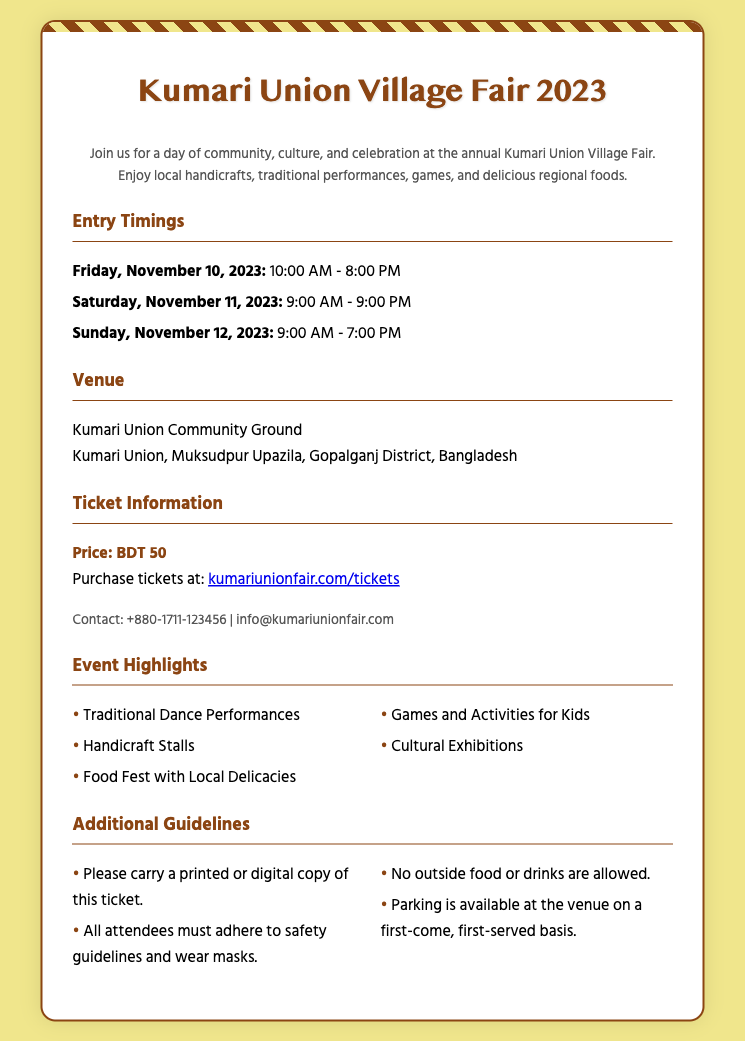What are the entry timings for Friday? The entry timing for Friday is listed prominently in the document under Entry Timings section.
Answer: 10:00 AM - 8:00 PM What is the price of the ticket? The price of the ticket is specified clearly in the Ticket Information section.
Answer: BDT 50 Where is the fair being held? The venue for the fair is provided in detail in the Venue section.
Answer: Kumari Union Community Ground What dates does the Village Fair take place? The dates for the Village Fair are mentioned in the Entry Timings section.
Answer: November 10-12, 2023 What is one of the event highlights? The highlights of the event are listed in the Event Highlights section, allowing for selection of any item.
Answer: Traditional Dance Performances What is the contact number for inquiries? The contact information is provided explicitly in the Ticket Information section.
Answer: +880-1711-123456 What is required to enter the event? The Additional Guidelines section mentions a requirement for ticket entry.
Answer: Printed or digital copy of this ticket How long is the Village Fair open on Saturday? The duration for Saturday's opening is listed in the Entry Timings section.
Answer: 9:00 AM - 9:00 PM What should attendees not bring to the event? The Additional Guidelines section specifies items that are prohibited at the event.
Answer: Outside food or drinks 